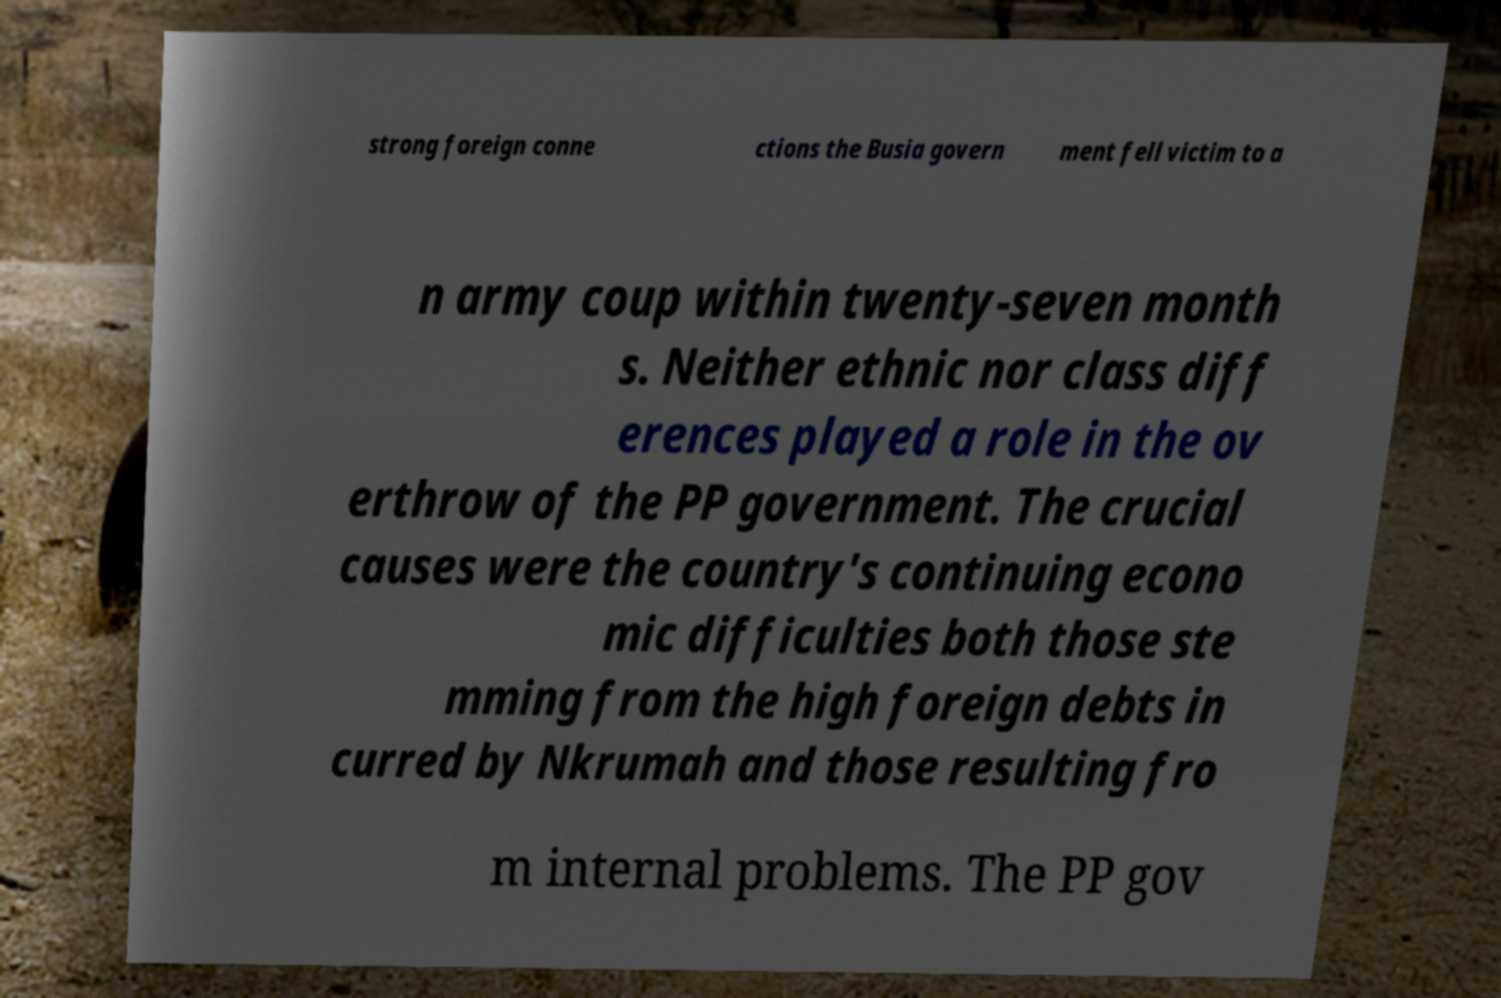Could you extract and type out the text from this image? strong foreign conne ctions the Busia govern ment fell victim to a n army coup within twenty-seven month s. Neither ethnic nor class diff erences played a role in the ov erthrow of the PP government. The crucial causes were the country's continuing econo mic difficulties both those ste mming from the high foreign debts in curred by Nkrumah and those resulting fro m internal problems. The PP gov 